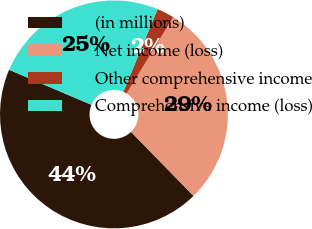Convert chart. <chart><loc_0><loc_0><loc_500><loc_500><pie_chart><fcel>(in millions)<fcel>Net income (loss)<fcel>Other comprehensive income<fcel>Comprehensive income (loss)<nl><fcel>43.71%<fcel>28.98%<fcel>2.46%<fcel>24.85%<nl></chart> 